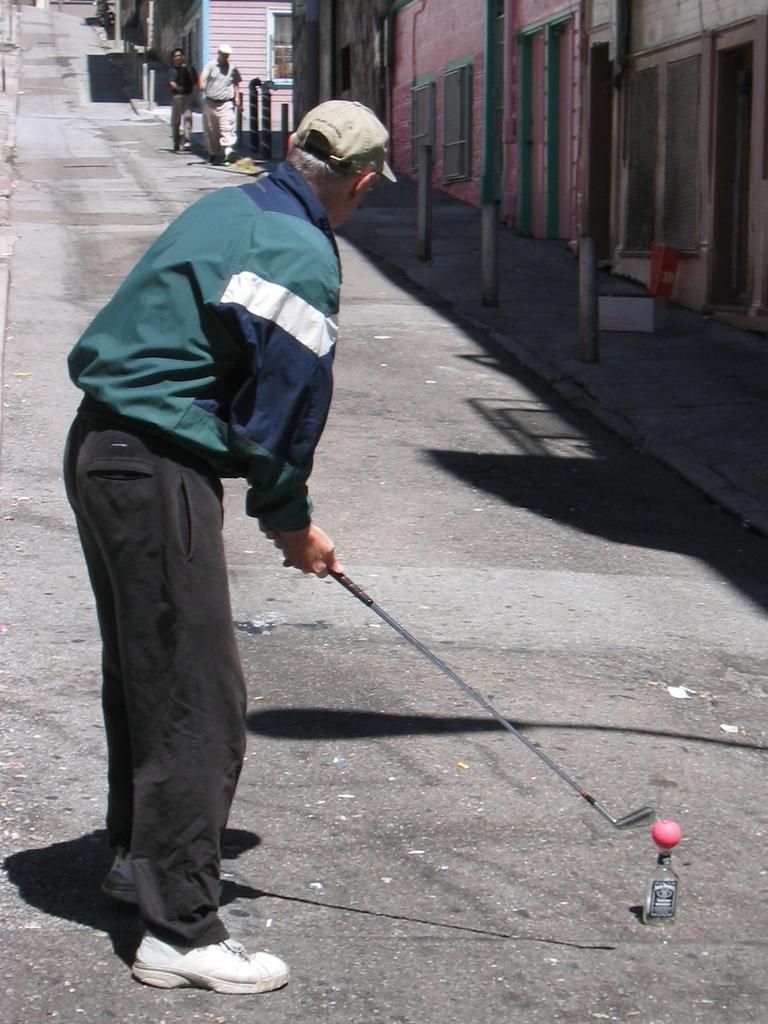In one or two sentences, can you explain what this image depicts? In this image we can see a person standing and holding a hockey stick, also we can see a bottle and a ball on it, there are two persons walking on the road, on the left side of the image we can see a few buildings, windows and poles. 